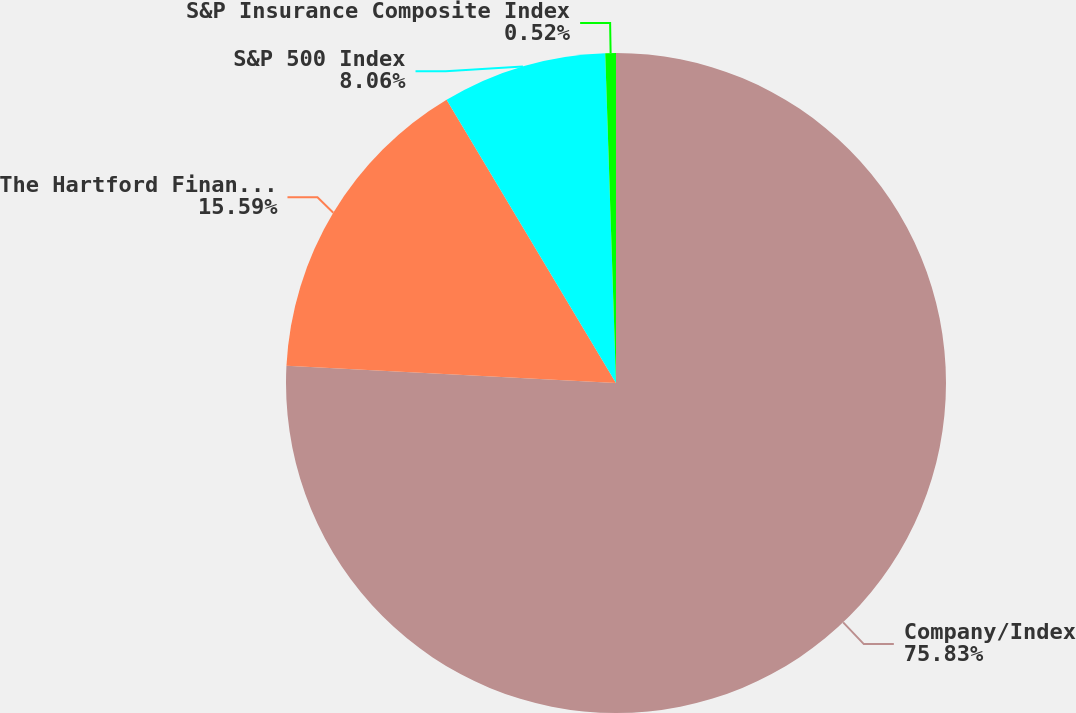Convert chart. <chart><loc_0><loc_0><loc_500><loc_500><pie_chart><fcel>Company/Index<fcel>The Hartford Financial<fcel>S&P 500 Index<fcel>S&P Insurance Composite Index<nl><fcel>75.83%<fcel>15.59%<fcel>8.06%<fcel>0.52%<nl></chart> 